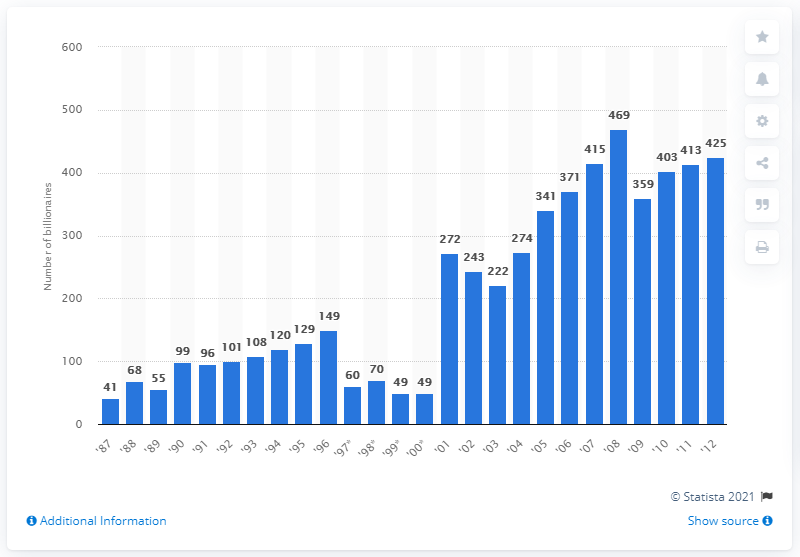Highlight a few significant elements in this photo. There were 425 billionaires in the United States in 2012. In 1987, there were 41 billionaires in the United States. 